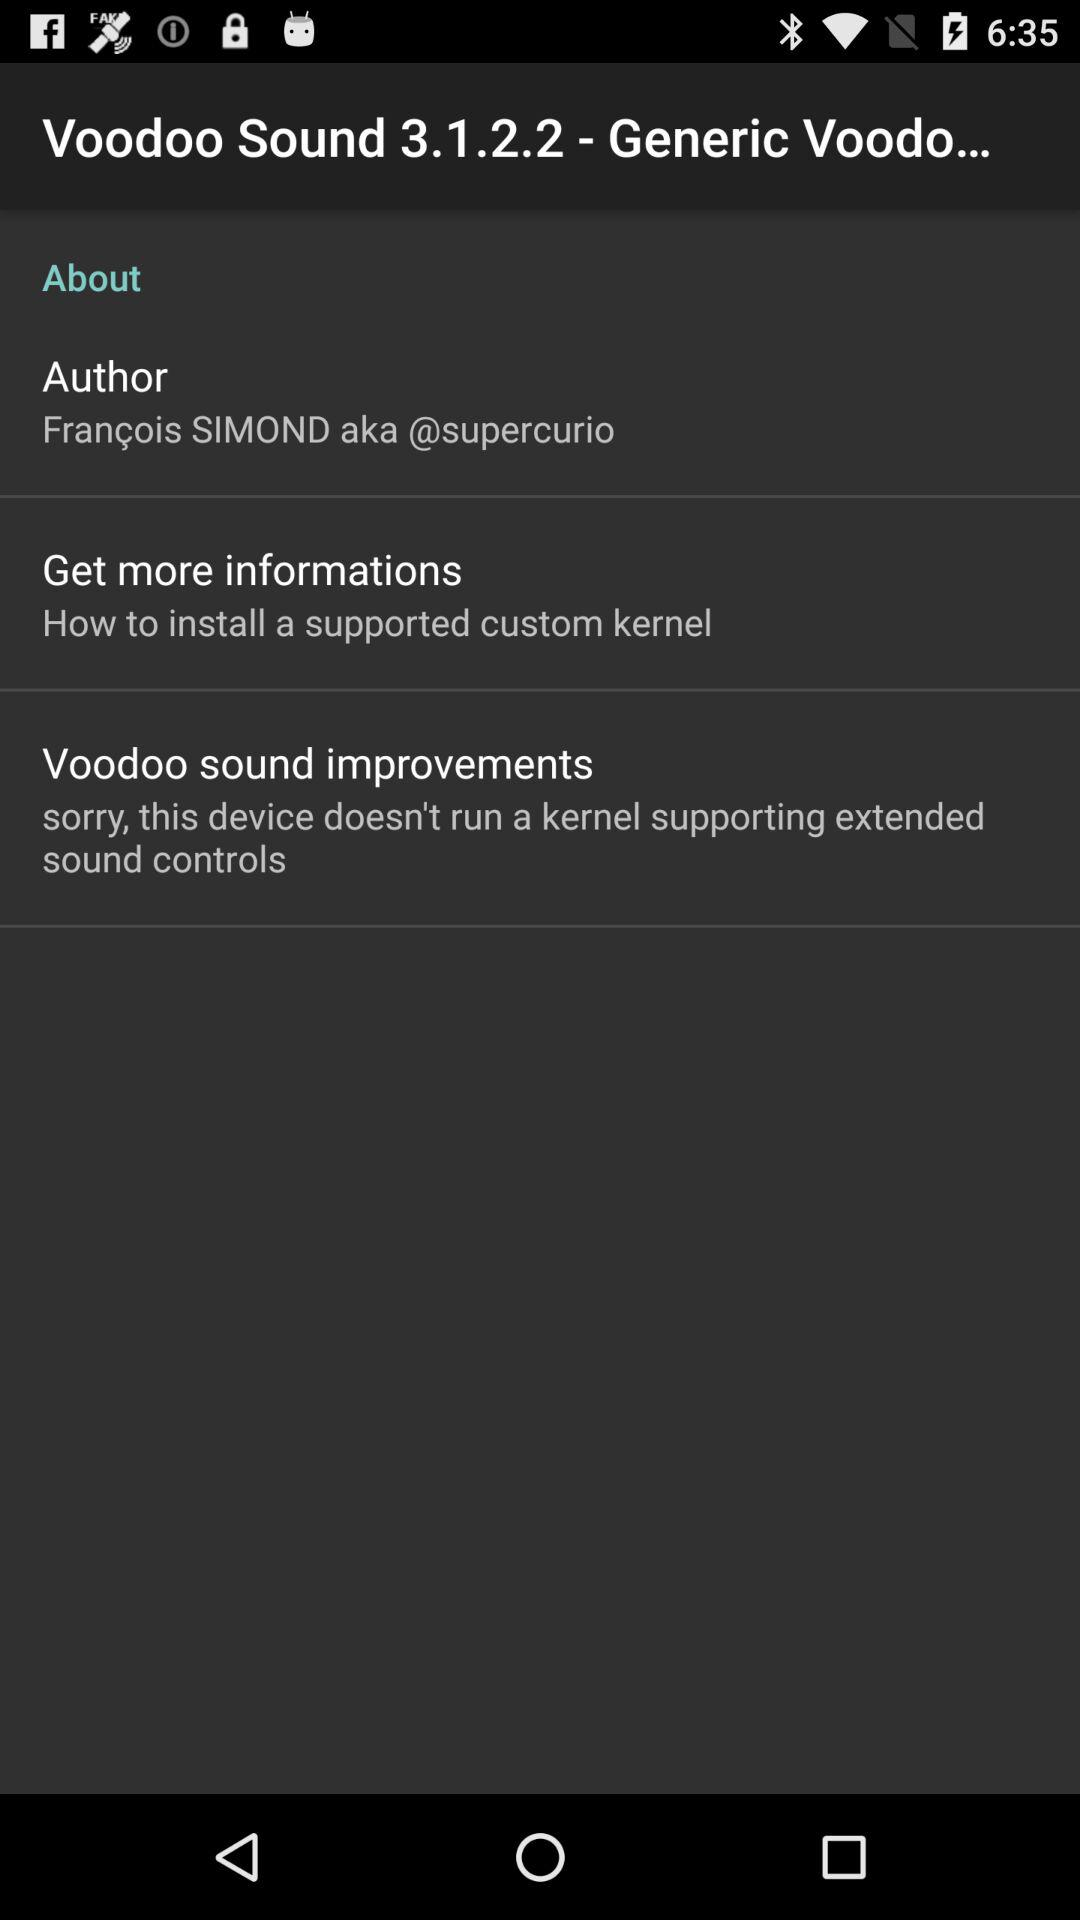Who is the author of "Voodoo Sound 3.1.2.2 - Generic Voodo..."? The author of "Voodoo Sound 3.1.2.2 - Generic Voodo..." is François Simond. 